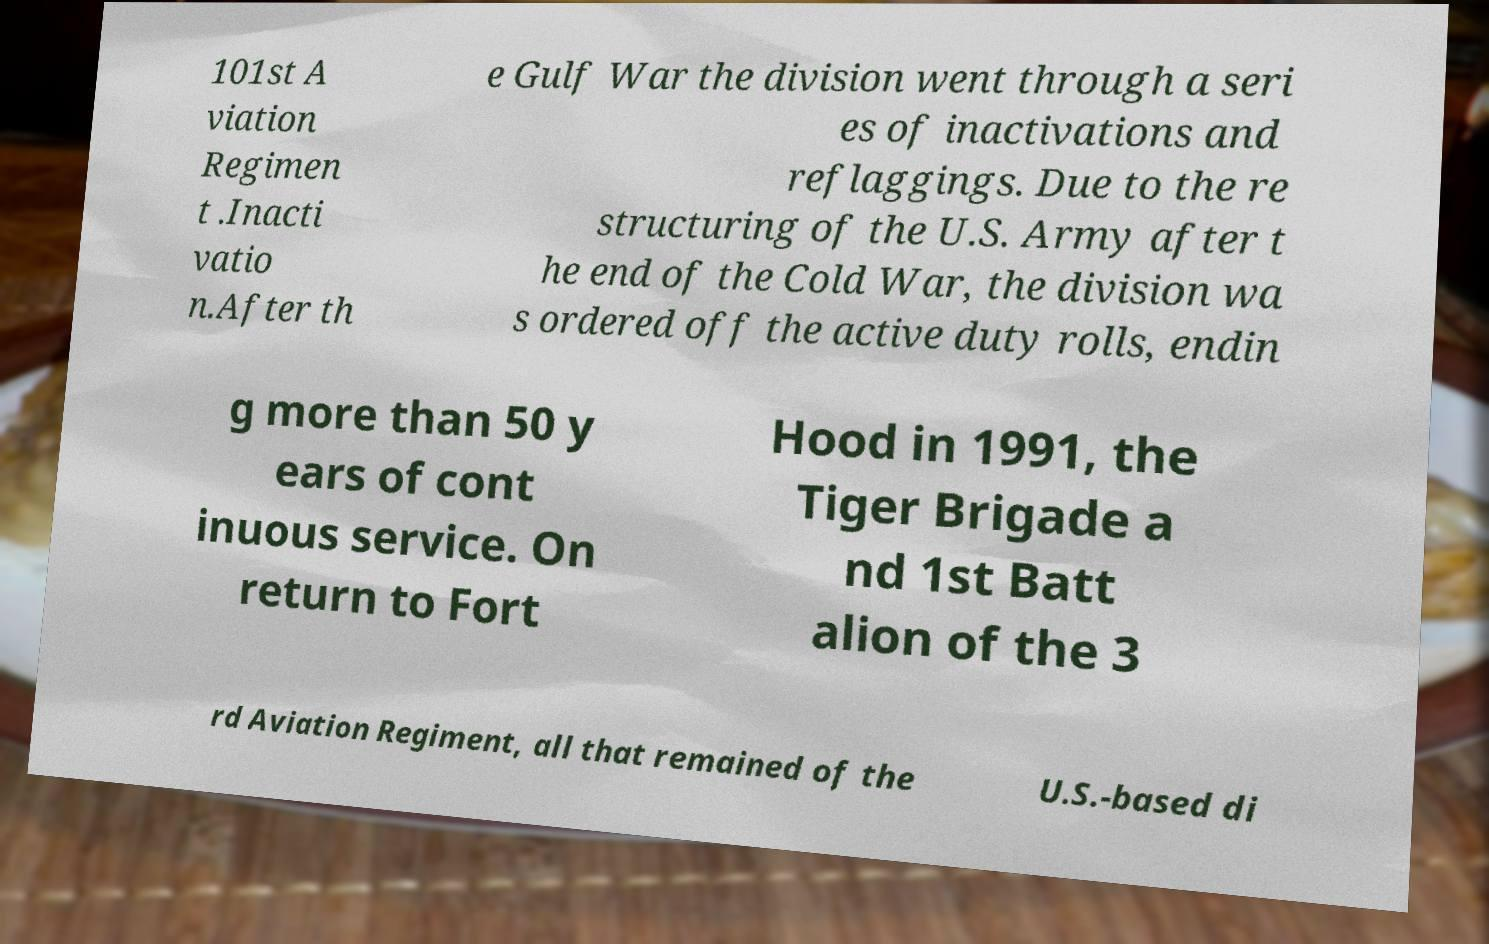Can you accurately transcribe the text from the provided image for me? 101st A viation Regimen t .Inacti vatio n.After th e Gulf War the division went through a seri es of inactivations and reflaggings. Due to the re structuring of the U.S. Army after t he end of the Cold War, the division wa s ordered off the active duty rolls, endin g more than 50 y ears of cont inuous service. On return to Fort Hood in 1991, the Tiger Brigade a nd 1st Batt alion of the 3 rd Aviation Regiment, all that remained of the U.S.-based di 